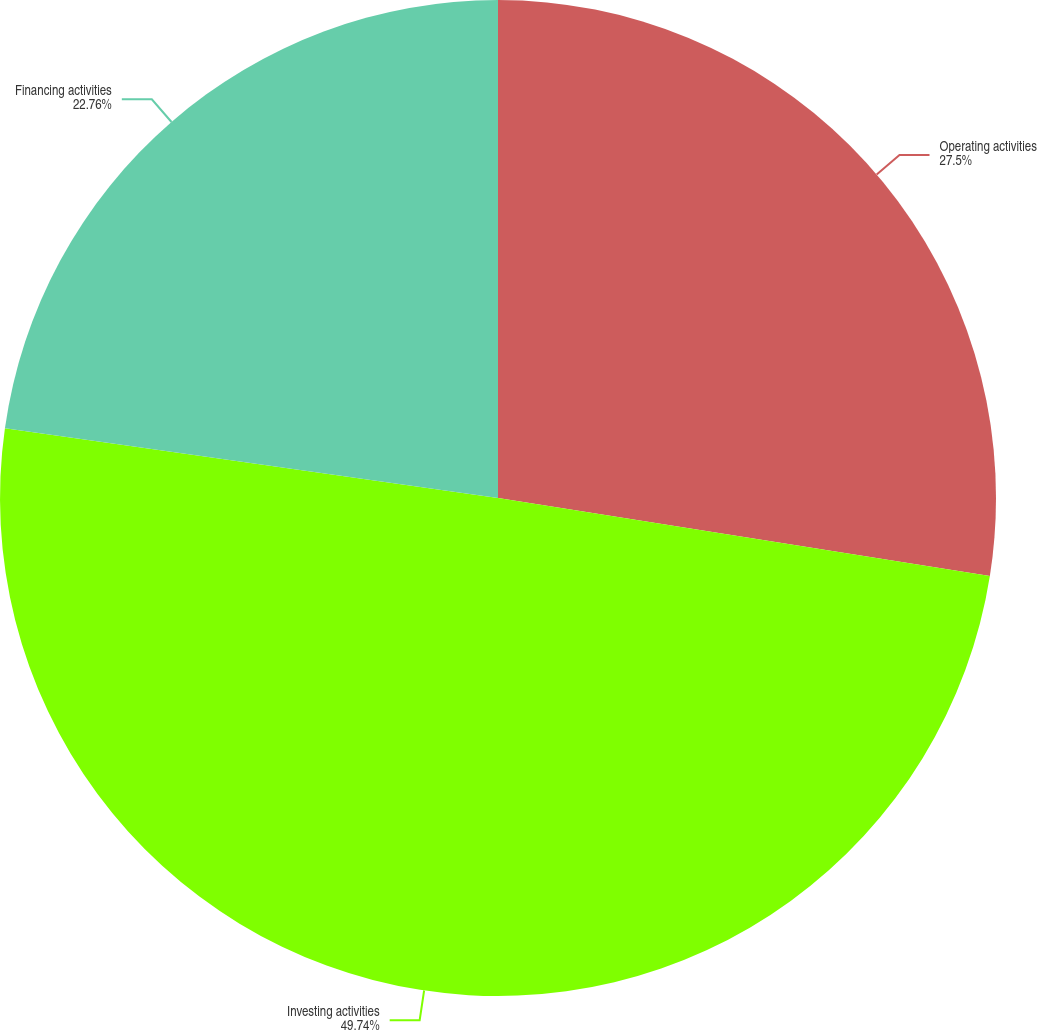Convert chart to OTSL. <chart><loc_0><loc_0><loc_500><loc_500><pie_chart><fcel>Operating activities<fcel>Investing activities<fcel>Financing activities<nl><fcel>27.5%<fcel>49.74%<fcel>22.76%<nl></chart> 